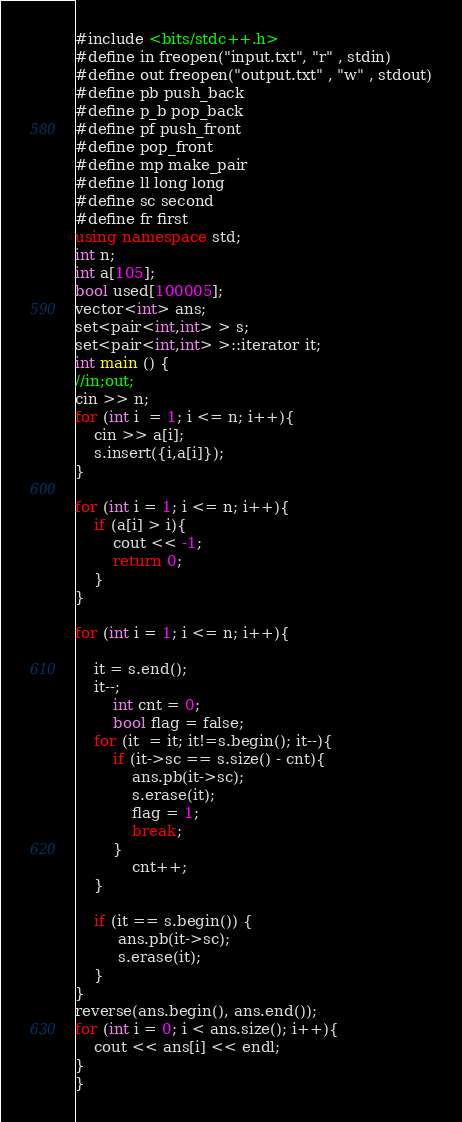Convert code to text. <code><loc_0><loc_0><loc_500><loc_500><_C++_>#include <bits/stdc++.h>
#define in freopen("input.txt", "r" , stdin)
#define out freopen("output.txt" , "w" , stdout)
#define pb push_back
#define p_b pop_back
#define pf push_front
#define pop_front
#define mp make_pair
#define ll long long
#define sc second
#define fr first
using namespace std;
int n;
int a[105];
bool used[100005];
vector<int> ans;
set<pair<int,int> > s;
set<pair<int,int> >::iterator it;
int main () {
//in;out;
cin >> n;
for (int i  = 1; i <= n; i++){
    cin >> a[i];
    s.insert({i,a[i]});
}

for (int i = 1; i <= n; i++){
    if (a[i] > i){
        cout << -1;
        return 0;
    }
}

for (int i = 1; i <= n; i++){

    it = s.end();
    it--;
        int cnt = 0;
        bool flag = false;
    for (it  = it; it!=s.begin(); it--){
        if (it->sc == s.size() - cnt){
            ans.pb(it->sc);
            s.erase(it);
            flag = 1;
            break;
        }
            cnt++;
    }

    if (it == s.begin()) {
         ans.pb(it->sc);
         s.erase(it);
    }
}
reverse(ans.begin(), ans.end());
for (int i = 0; i < ans.size(); i++){
    cout << ans[i] << endl;
}
}
</code> 